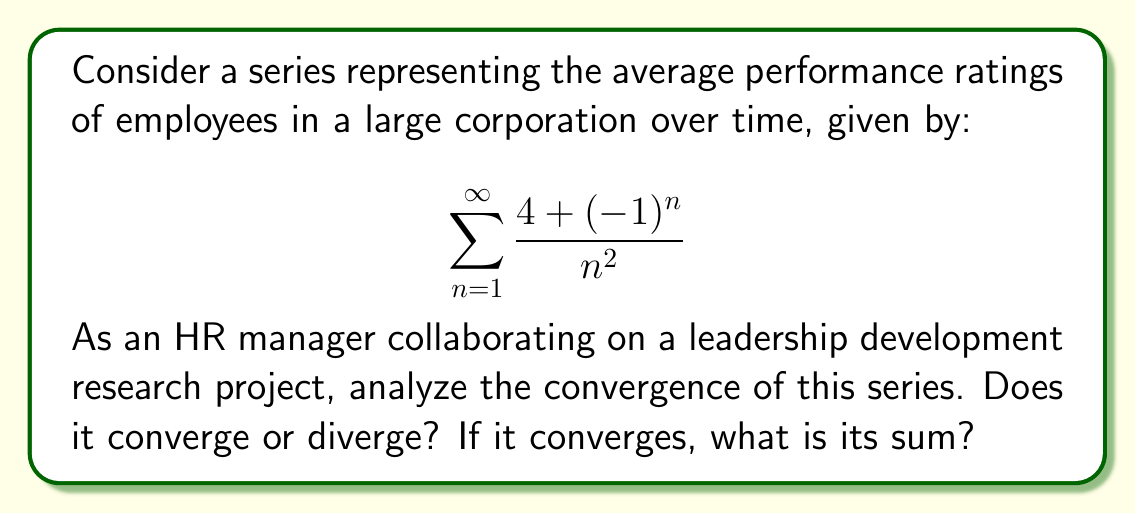Give your solution to this math problem. To analyze the convergence of this series, we'll follow these steps:

1) First, let's consider the general term of the series:

   $$a_n = \frac{4 + (-1)^n}{n^2}$$

2) We can split this into two series:

   $$\sum_{n=1}^{\infty} \frac{4}{n^2} + \sum_{n=1}^{\infty} \frac{(-1)^n}{n^2}$$

3) Let's analyze each series separately:

   a) $\sum_{n=1}^{\infty} \frac{4}{n^2}$:
      This is a constant multiple of the p-series $\sum_{n=1}^{\infty} \frac{1}{n^2}$. We know that p-series converge for p > 1, and here p = 2. Therefore, this series converges.
      In fact, we know that $\sum_{n=1}^{\infty} \frac{1}{n^2} = \frac{\pi^2}{6}$.
      So, $\sum_{n=1}^{\infty} \frac{4}{n^2} = 4 \cdot \frac{\pi^2}{6} = \frac{2\pi^2}{3}$.

   b) $\sum_{n=1}^{\infty} \frac{(-1)^n}{n^2}$:
      This is the alternating harmonic series of order 2. It converges by the alternating series test, as $\frac{1}{n^2}$ is decreasing and approaches 0 as n approaches infinity.
      This series is known as the Dirichlet eta function for s=2, and its sum is $-\frac{\pi^2}{12}$.

4) Since both series converge, their sum converges. The sum of the original series is:

   $$\frac{2\pi^2}{3} + (-\frac{\pi^2}{12}) = \frac{8\pi^2}{12} - \frac{\pi^2}{12} = \frac{7\pi^2}{12}$$

Therefore, the series converges, and its sum is $\frac{7\pi^2}{12}$.

In the context of employee performance ratings, this convergence suggests that the long-term average of performance ratings stabilizes over time, providing a reliable metric for the HR manager's leadership development research.
Answer: The series converges, and its sum is $\frac{7\pi^2}{12}$. 